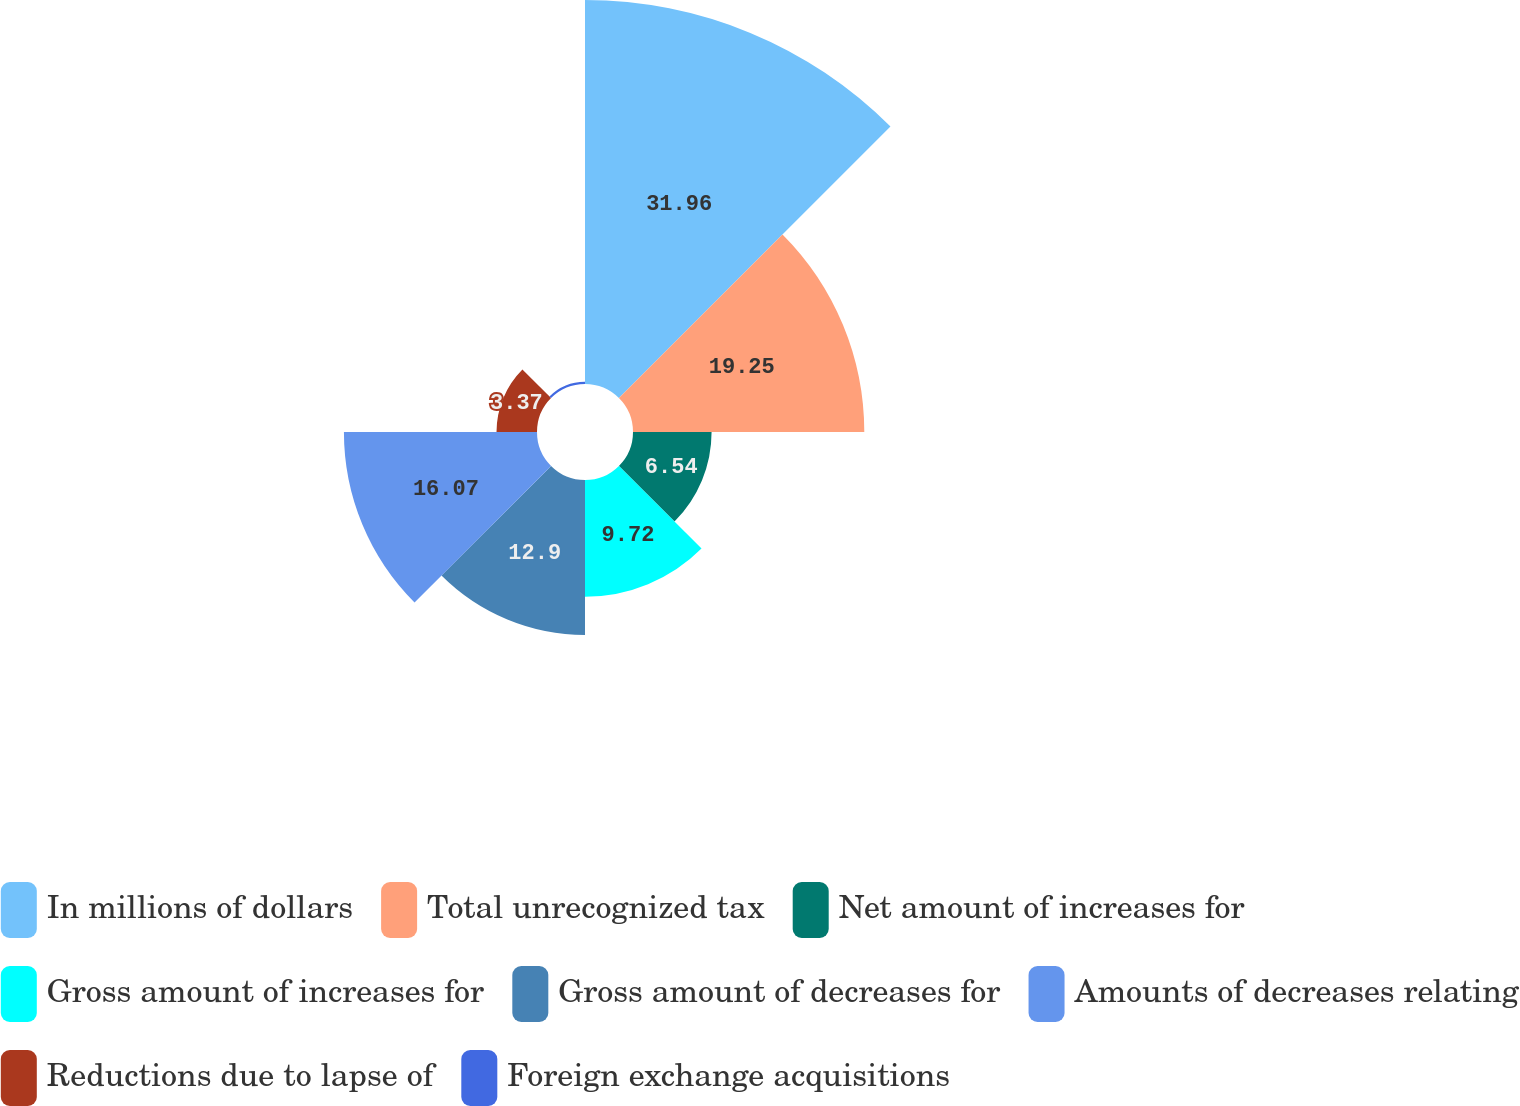Convert chart. <chart><loc_0><loc_0><loc_500><loc_500><pie_chart><fcel>In millions of dollars<fcel>Total unrecognized tax<fcel>Net amount of increases for<fcel>Gross amount of increases for<fcel>Gross amount of decreases for<fcel>Amounts of decreases relating<fcel>Reductions due to lapse of<fcel>Foreign exchange acquisitions<nl><fcel>31.96%<fcel>19.25%<fcel>6.54%<fcel>9.72%<fcel>12.9%<fcel>16.07%<fcel>3.37%<fcel>0.19%<nl></chart> 